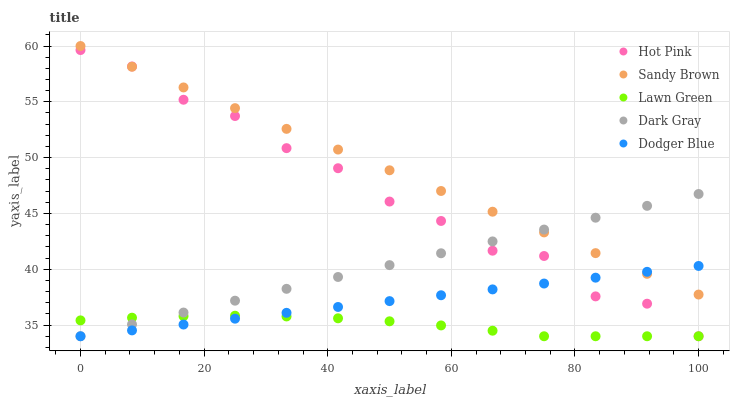Does Lawn Green have the minimum area under the curve?
Answer yes or no. Yes. Does Sandy Brown have the maximum area under the curve?
Answer yes or no. Yes. Does Hot Pink have the minimum area under the curve?
Answer yes or no. No. Does Hot Pink have the maximum area under the curve?
Answer yes or no. No. Is Dark Gray the smoothest?
Answer yes or no. Yes. Is Hot Pink the roughest?
Answer yes or no. Yes. Is Lawn Green the smoothest?
Answer yes or no. No. Is Lawn Green the roughest?
Answer yes or no. No. Does Dark Gray have the lowest value?
Answer yes or no. Yes. Does Sandy Brown have the lowest value?
Answer yes or no. No. Does Sandy Brown have the highest value?
Answer yes or no. Yes. Does Hot Pink have the highest value?
Answer yes or no. No. Is Lawn Green less than Sandy Brown?
Answer yes or no. Yes. Is Sandy Brown greater than Lawn Green?
Answer yes or no. Yes. Does Sandy Brown intersect Hot Pink?
Answer yes or no. Yes. Is Sandy Brown less than Hot Pink?
Answer yes or no. No. Is Sandy Brown greater than Hot Pink?
Answer yes or no. No. Does Lawn Green intersect Sandy Brown?
Answer yes or no. No. 